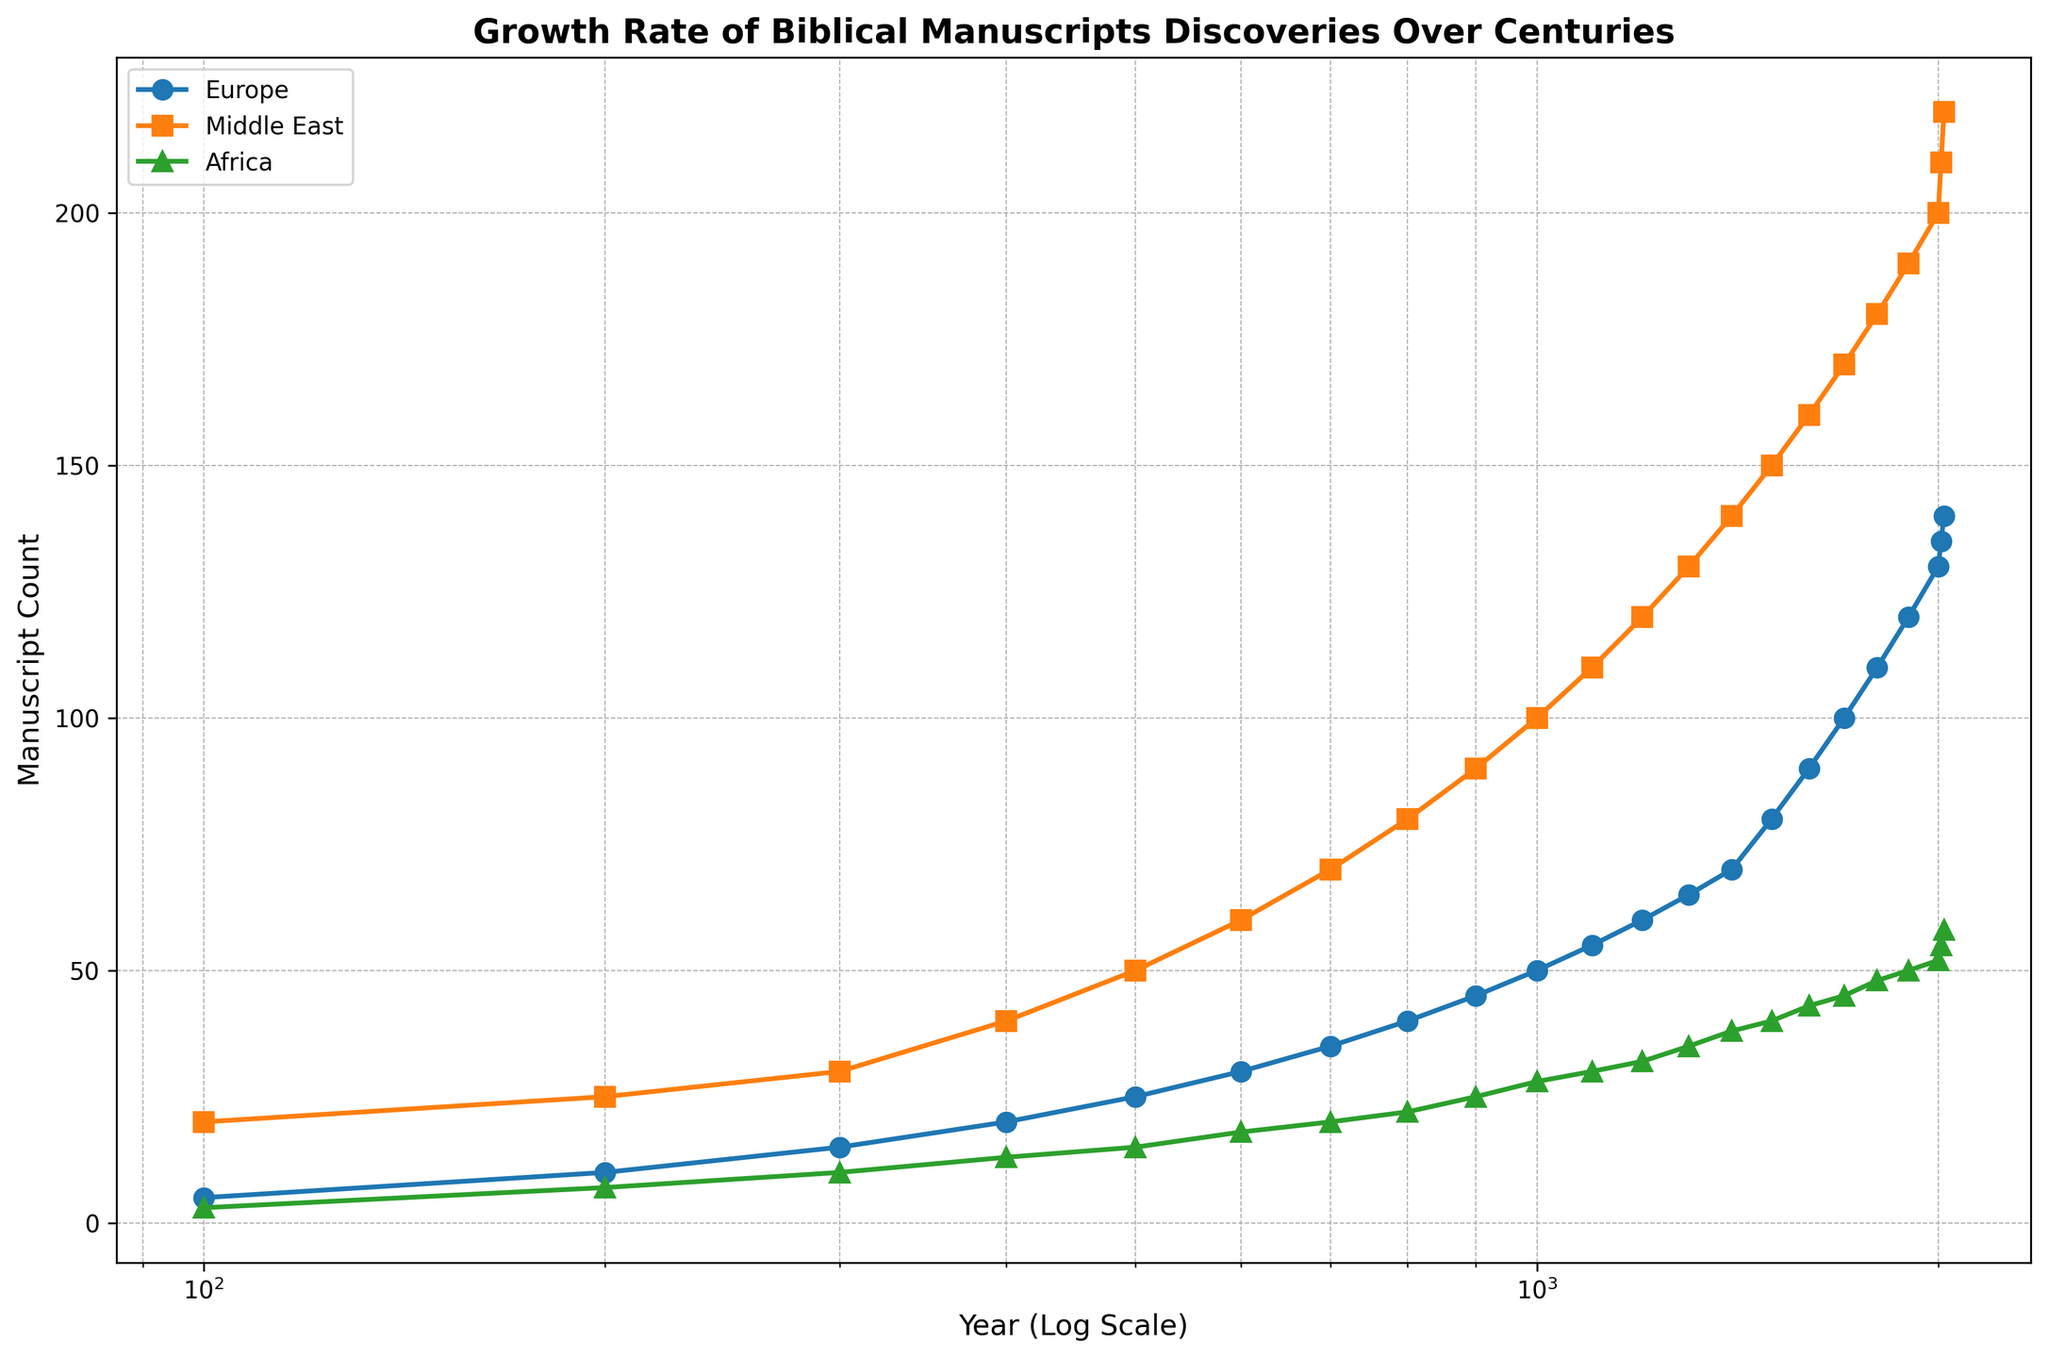What is the trend in the Manuscript Count for Europe from 100 to 2020? The line for Europe (blue line with round markers) shows a steady increase in the Manuscript Count from 5 manuscripts in the year 100 to 140 manuscripts in 2020. The Log Scale on the x-axis emphasizes that the growth is especially noticeable in the later centuries.
Answer: Steady increase Which geographic region had the highest manuscript count in the year 1400? By tracing the vertical line from the year 1400 upwards, it's clear that the Middle East (depicted by the orange line with square markers) had the highest Manuscript Count, reaching 140 manuscripts compared to Europe (70 manuscripts) and Africa (38 manuscripts).
Answer: Middle East At which point in time did Africa's Manuscript Count first exceed 50? Following the green line with the triangular markers for Africa, it first exceeds 50 manuscripts around the year 2010.
Answer: 2010 How does the Manuscript Count in the Middle East in the year 800 compare to Europe in the year 1300? The Manuscript Count in the Middle East in 800 is 80 (orange line with square markers) while in Europe in 1300 is 65 (blue line with round markers). By comparison, the Middle East has a higher manuscript count in 800 relative to Europe's count in 1300.
Answer: Middle East is higher What is the combined Manuscript Count for Europe and Africa in the year 1000? By locating the points for Europe and Africa on the graph at the year 1000, Europe has 50 manuscripts and Africa has 28 manuscripts. Adding these together, the combined Manuscript Count is 50 + 28 = 78.
Answer: 78 Which region shows the largest increase in Manuscript Count between the years 1500 and 2000? Between 1500 and 2000, Europe increases from 80 to 130 (50 increase), the Middle East from 150 to 200 (50 increase), and Africa from 40 to 52 (12 increase). Both Europe and the Middle East show larger increases of 50 documents, compared to Africa’s 12.
Answer: Europe and Middle East What's the difference in Manuscript Count between the Middle East and Africa in the year 2020? In 2020, the Manuscript Count for the Middle East is 220 and for Africa is 58. The difference is computed as 220 - 58 = 162.
Answer: 162 What color represents the region of Africa in the figure? By examining the colors used in the graph, Africa is represented by the green line with triangular markers.
Answer: Green 